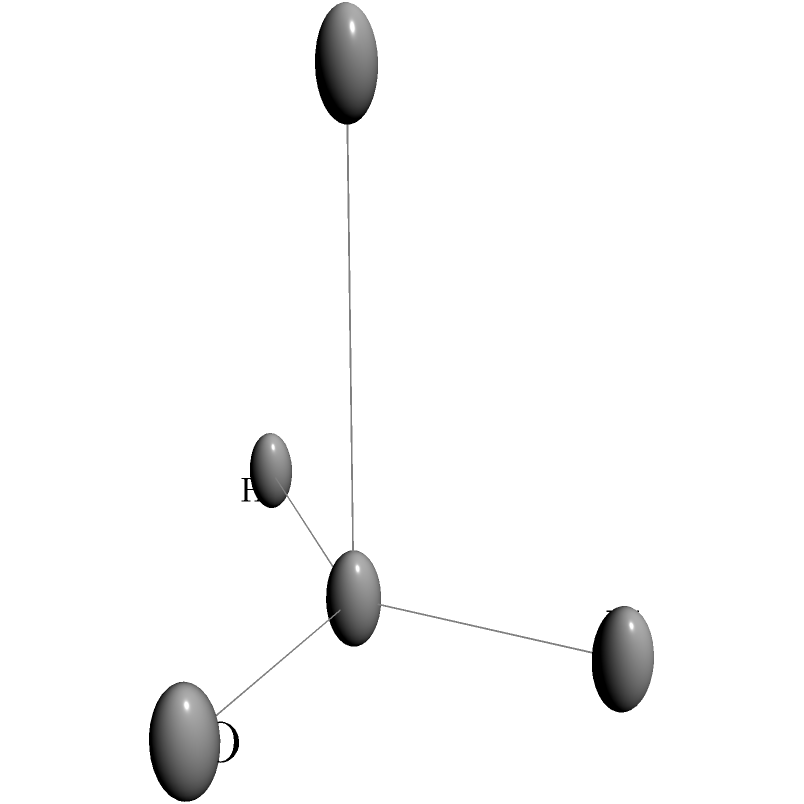Analyze the 3D molecular structure shown above. What is the molecular geometry around the central carbon atom, and how many sigma ($\sigma$) and pi ($\pi$) bonds are present in this molecule? To analyze the structure and bonding in this molecule, let's follow these steps:

1. Identify the central atom:
   The central atom is carbon (C), as it is bonded to four other atoms.

2. Determine the molecular geometry:
   - The carbon atom is bonded to four different atoms (O, N, H, and S).
   - These four bonds are arranged in a tetrahedral geometry around the central carbon.
   - The bond angles are approximately 109.5°, which is characteristic of sp³ hybridization.

3. Count the number of sigma ($\sigma$) bonds:
   - Each single bond represents a sigma bond.
   - There are four single bonds from the central carbon to O, N, H, and S.
   - Therefore, there are 4 sigma bonds in total.

4. Identify any pi ($\pi$) bonds:
   - Pi bonds are typically found in double or triple bonds.
   - In this molecule, all bonds appear to be single bonds.
   - There are no visible pi bonds in this structure.

5. Conclusion:
   - The molecular geometry around the central carbon is tetrahedral.
   - The molecule contains 4 sigma bonds and 0 pi bonds.
Answer: Tetrahedral geometry; 4 $\sigma$ bonds, 0 $\pi$ bonds 